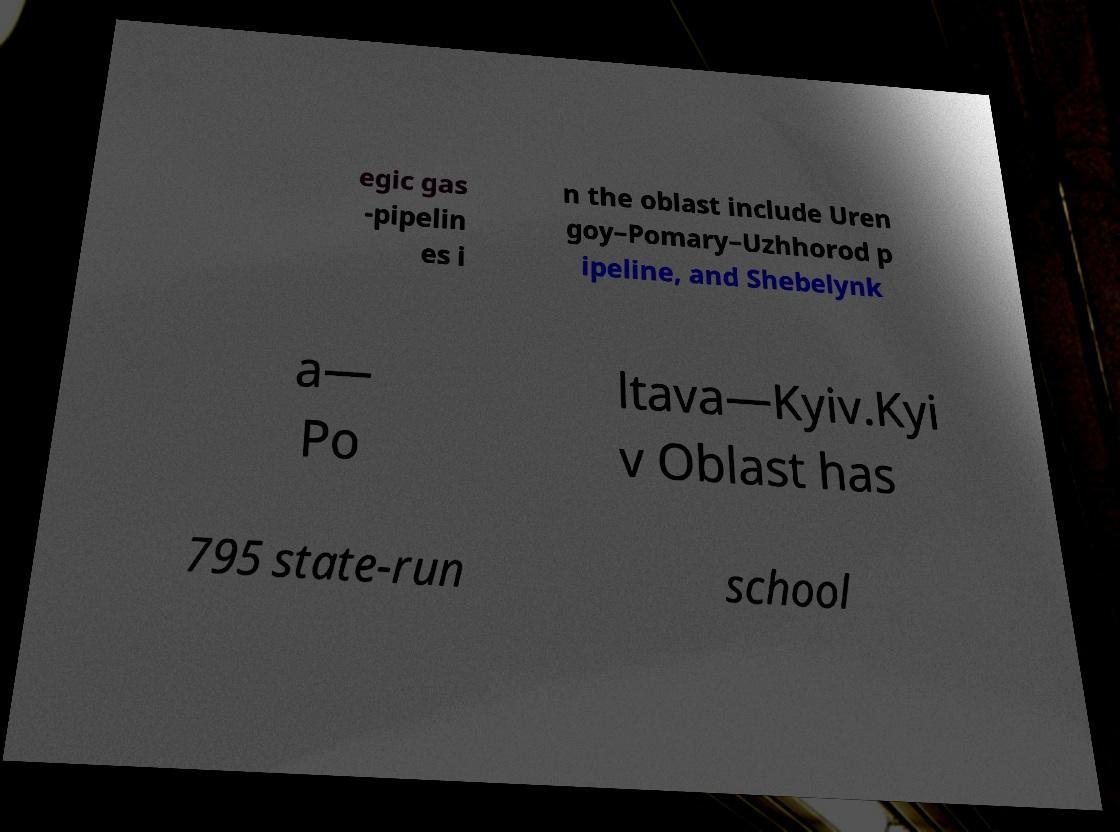Could you extract and type out the text from this image? egic gas -pipelin es i n the oblast include Uren goy–Pomary–Uzhhorod p ipeline, and Shebelynk a— Po ltava—Kyiv.Kyi v Oblast has 795 state-run school 